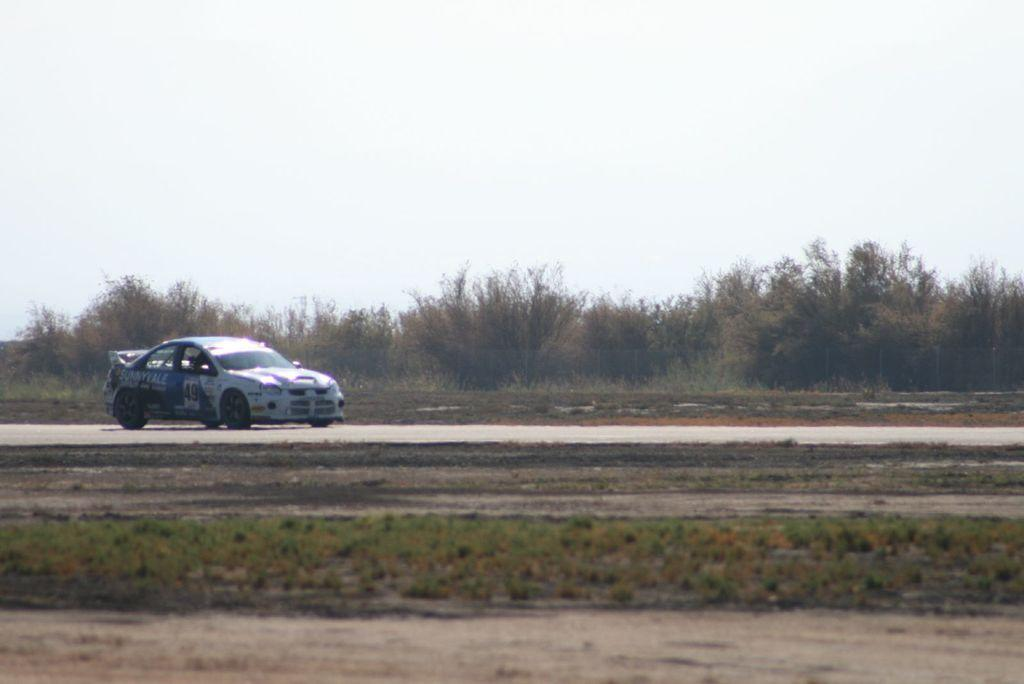What is the main subject of the image? There is a vehicle on the road in the image. What can be seen beside the road in the image? There are trees beside the road in the image. How would you describe the sky in the image? The sky is clear in the image. How many mountains can be seen in the image? There are no mountains visible in the image; it features a vehicle on the road with trees beside it and a clear sky. What type of twig is present in the image? There is no twig present in the image. 